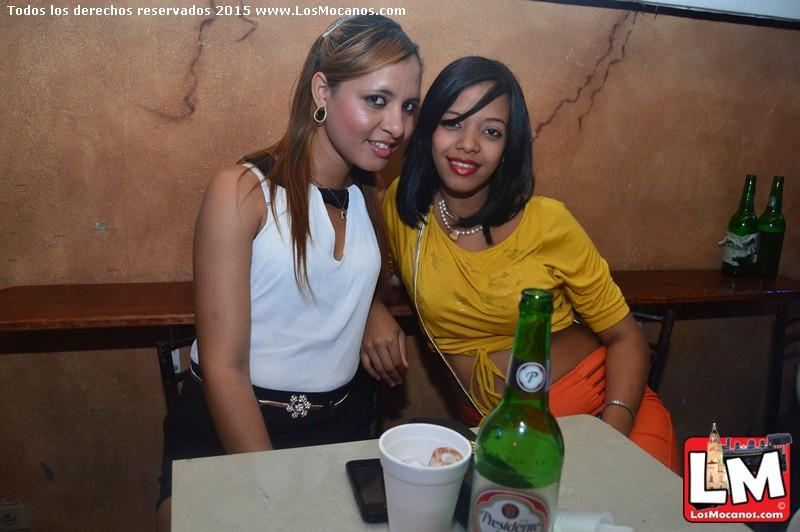How many people are in the image? There are two ladies in the image. What are the ladies doing in the image? The ladies are sitting in chairs. What is in front of the ladies? There is a table in front of the ladies. What objects can be seen on the table? There is a green bottle, a cup, a mobile phone, and a purse on the table. What type of plastic material is used to make the respect in the image? There is no mention of respect or any plastic material in the image. The image features two ladies sitting in chairs with a table in front of them, containing a green bottle, a cup, a mobile phone, and a purse. 